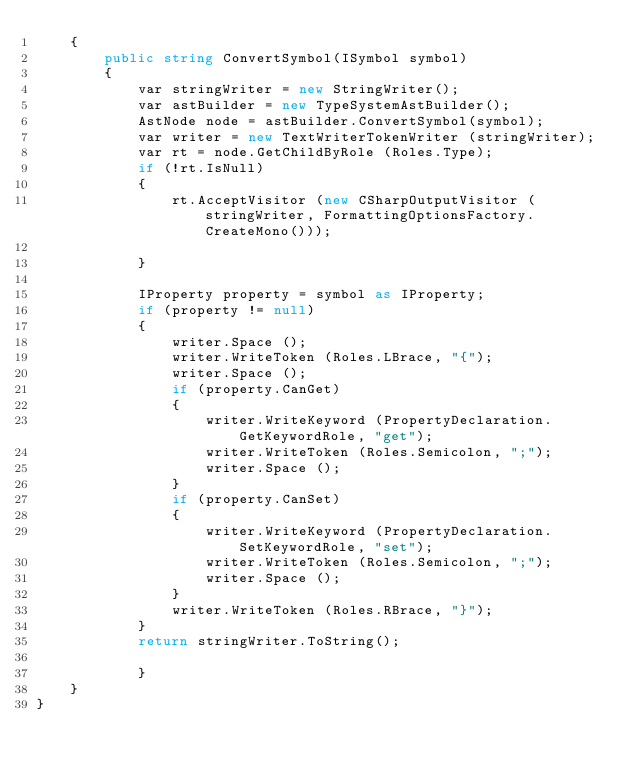<code> <loc_0><loc_0><loc_500><loc_500><_C#_>    {
        public string ConvertSymbol(ISymbol symbol)
        {
            var stringWriter = new StringWriter();
            var astBuilder = new TypeSystemAstBuilder();
            AstNode node = astBuilder.ConvertSymbol(symbol);
            var writer = new TextWriterTokenWriter (stringWriter);
            var rt = node.GetChildByRole (Roles.Type);
            if (!rt.IsNull)
            {
                rt.AcceptVisitor (new CSharpOutputVisitor (stringWriter, FormattingOptionsFactory.CreateMono()));

            }

            IProperty property = symbol as IProperty;
            if (property != null)
            {
                writer.Space ();
                writer.WriteToken (Roles.LBrace, "{");
                writer.Space ();
                if (property.CanGet)
                {
                    writer.WriteKeyword (PropertyDeclaration.GetKeywordRole, "get");
                    writer.WriteToken (Roles.Semicolon, ";");
                    writer.Space ();
                }
                if (property.CanSet)
                {
                    writer.WriteKeyword (PropertyDeclaration.SetKeywordRole, "set");
                    writer.WriteToken (Roles.Semicolon, ";");
                    writer.Space ();
                }
                writer.WriteToken (Roles.RBrace, "}");
            }
            return stringWriter.ToString();

            }
    }
}
</code> 